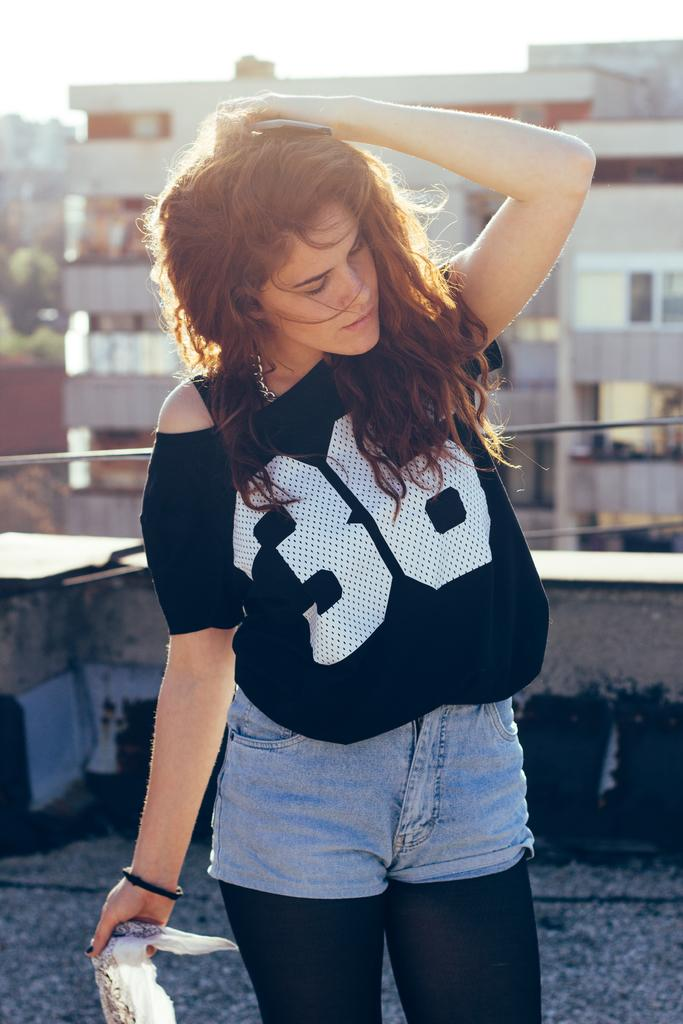Who is the main subject in the image? There is a girl standing in the middle of the image. What can be seen in the background of the image? There are buildings in the background of the image. What is visible at the top of the image? The sky is visible at the top of the image. What type of magic is the girl performing in the image? There is no indication of magic or any magical activity in the image. 